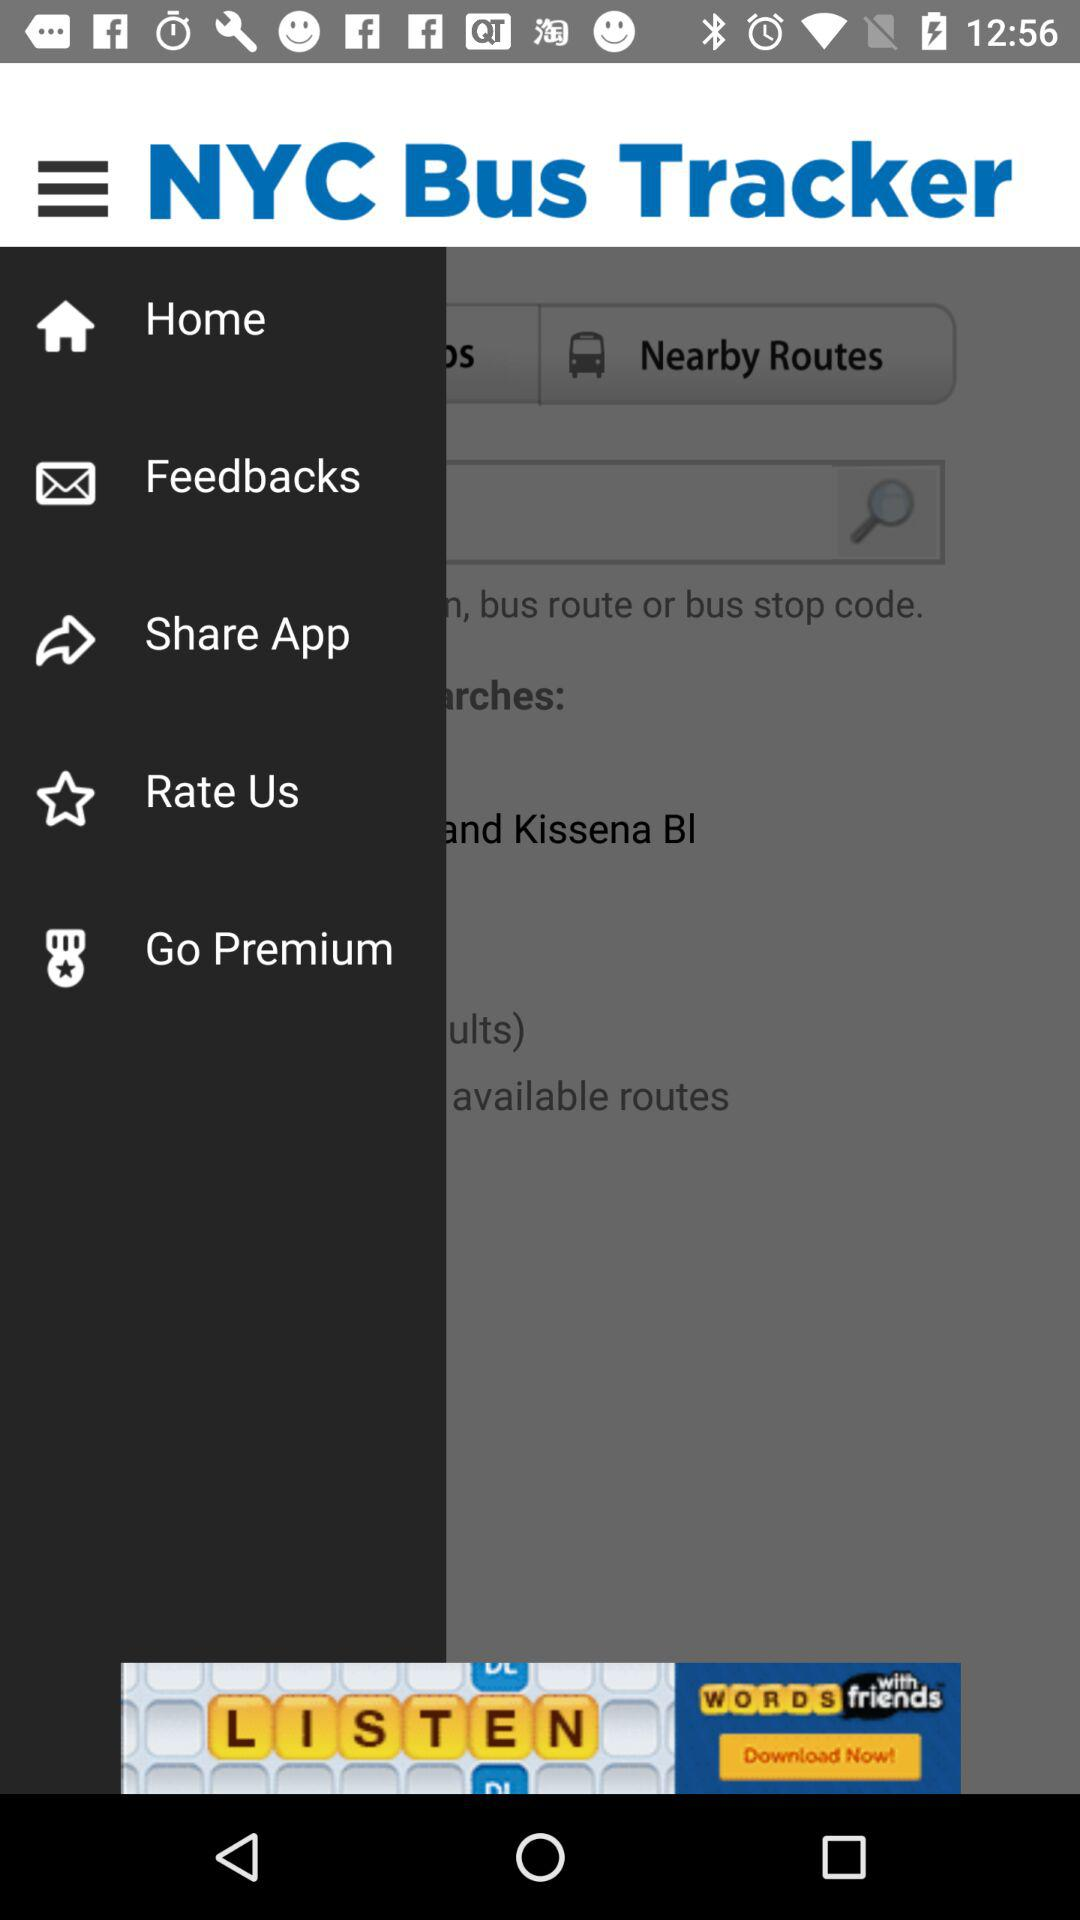What is the app name? The app name is "NYC Bus Tracker". 